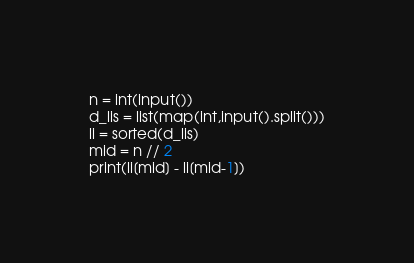<code> <loc_0><loc_0><loc_500><loc_500><_Python_>n = int(input())
d_lis = list(map(int,input().split()))
li = sorted(d_lis)
mid = n // 2
print(li[mid] - li[mid-1])</code> 